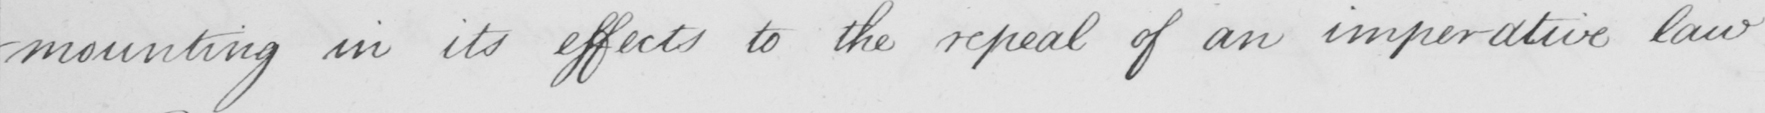What does this handwritten line say? -mounting in its effects to the repeal of an imperative law 